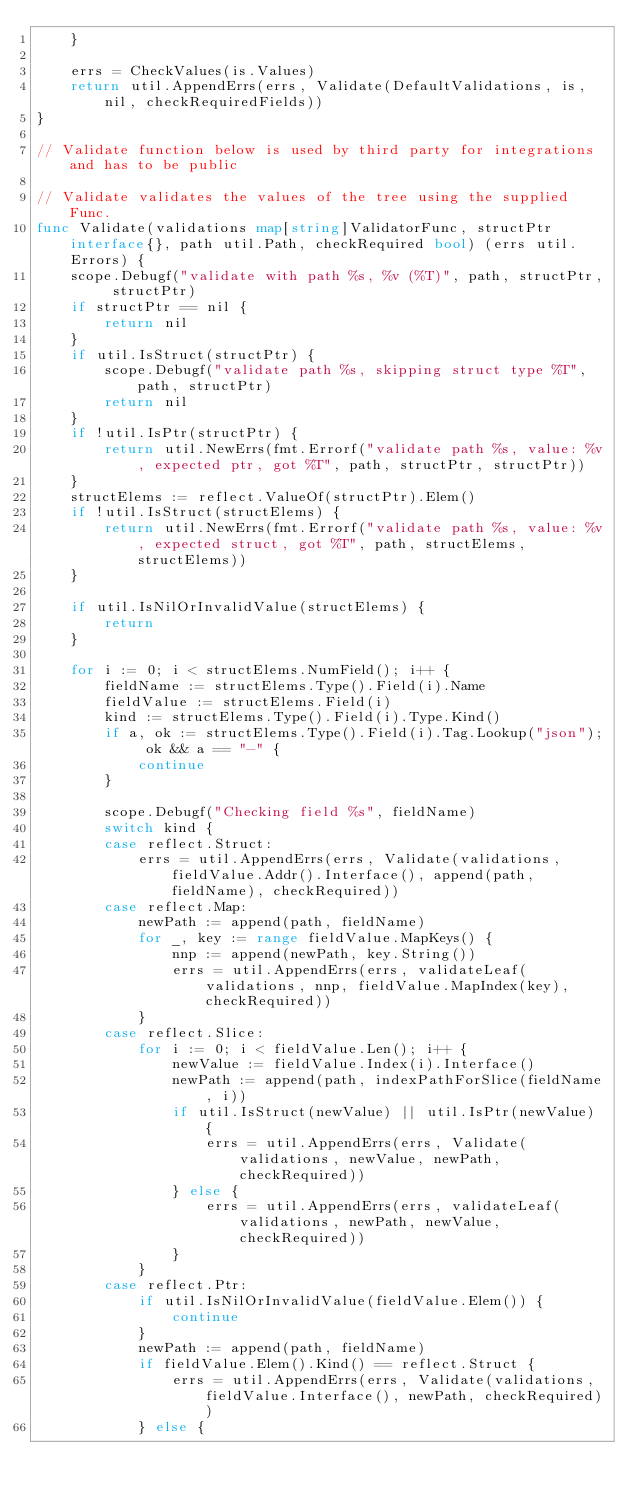<code> <loc_0><loc_0><loc_500><loc_500><_Go_>	}

	errs = CheckValues(is.Values)
	return util.AppendErrs(errs, Validate(DefaultValidations, is, nil, checkRequiredFields))
}

// Validate function below is used by third party for integrations and has to be public

// Validate validates the values of the tree using the supplied Func.
func Validate(validations map[string]ValidatorFunc, structPtr interface{}, path util.Path, checkRequired bool) (errs util.Errors) {
	scope.Debugf("validate with path %s, %v (%T)", path, structPtr, structPtr)
	if structPtr == nil {
		return nil
	}
	if util.IsStruct(structPtr) {
		scope.Debugf("validate path %s, skipping struct type %T", path, structPtr)
		return nil
	}
	if !util.IsPtr(structPtr) {
		return util.NewErrs(fmt.Errorf("validate path %s, value: %v, expected ptr, got %T", path, structPtr, structPtr))
	}
	structElems := reflect.ValueOf(structPtr).Elem()
	if !util.IsStruct(structElems) {
		return util.NewErrs(fmt.Errorf("validate path %s, value: %v, expected struct, got %T", path, structElems, structElems))
	}

	if util.IsNilOrInvalidValue(structElems) {
		return
	}

	for i := 0; i < structElems.NumField(); i++ {
		fieldName := structElems.Type().Field(i).Name
		fieldValue := structElems.Field(i)
		kind := structElems.Type().Field(i).Type.Kind()
		if a, ok := structElems.Type().Field(i).Tag.Lookup("json"); ok && a == "-" {
			continue
		}

		scope.Debugf("Checking field %s", fieldName)
		switch kind {
		case reflect.Struct:
			errs = util.AppendErrs(errs, Validate(validations, fieldValue.Addr().Interface(), append(path, fieldName), checkRequired))
		case reflect.Map:
			newPath := append(path, fieldName)
			for _, key := range fieldValue.MapKeys() {
				nnp := append(newPath, key.String())
				errs = util.AppendErrs(errs, validateLeaf(validations, nnp, fieldValue.MapIndex(key), checkRequired))
			}
		case reflect.Slice:
			for i := 0; i < fieldValue.Len(); i++ {
				newValue := fieldValue.Index(i).Interface()
				newPath := append(path, indexPathForSlice(fieldName, i))
				if util.IsStruct(newValue) || util.IsPtr(newValue) {
					errs = util.AppendErrs(errs, Validate(validations, newValue, newPath, checkRequired))
				} else {
					errs = util.AppendErrs(errs, validateLeaf(validations, newPath, newValue, checkRequired))
				}
			}
		case reflect.Ptr:
			if util.IsNilOrInvalidValue(fieldValue.Elem()) {
				continue
			}
			newPath := append(path, fieldName)
			if fieldValue.Elem().Kind() == reflect.Struct {
				errs = util.AppendErrs(errs, Validate(validations, fieldValue.Interface(), newPath, checkRequired))
			} else {</code> 